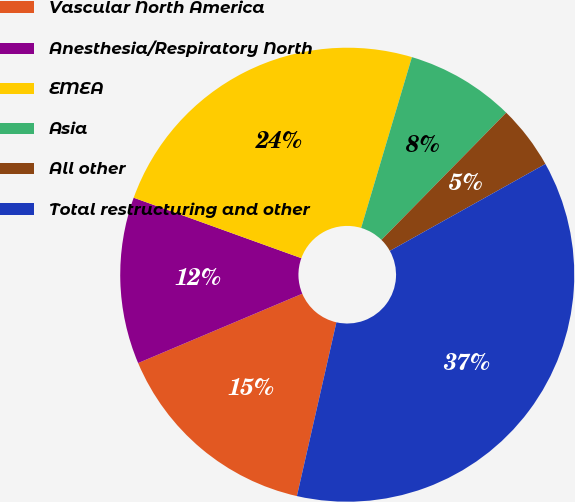<chart> <loc_0><loc_0><loc_500><loc_500><pie_chart><fcel>Vascular North America<fcel>Anesthesia/Respiratory North<fcel>EMEA<fcel>Asia<fcel>All other<fcel>Total restructuring and other<nl><fcel>15.08%<fcel>11.87%<fcel>24.09%<fcel>7.75%<fcel>4.54%<fcel>36.67%<nl></chart> 